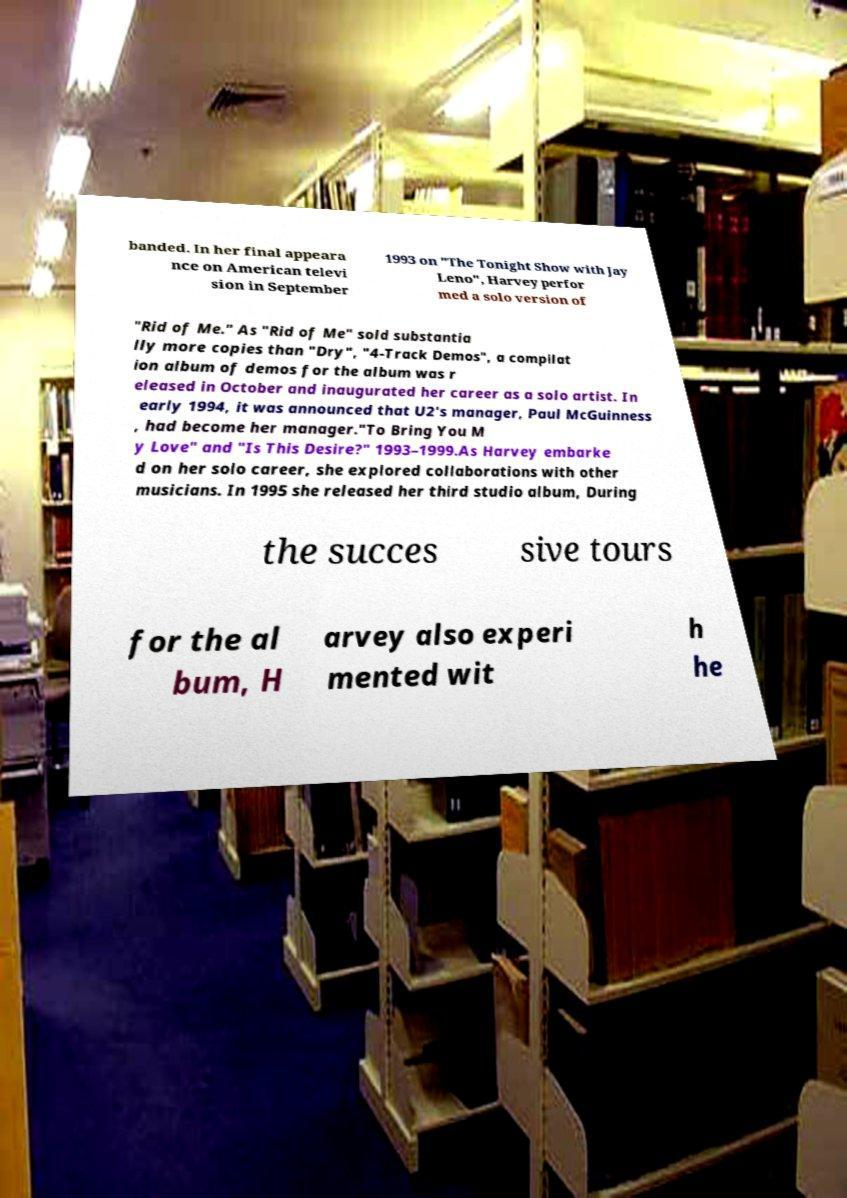For documentation purposes, I need the text within this image transcribed. Could you provide that? banded. In her final appeara nce on American televi sion in September 1993 on "The Tonight Show with Jay Leno", Harvey perfor med a solo version of "Rid of Me." As "Rid of Me" sold substantia lly more copies than "Dry", "4-Track Demos", a compilat ion album of demos for the album was r eleased in October and inaugurated her career as a solo artist. In early 1994, it was announced that U2's manager, Paul McGuinness , had become her manager."To Bring You M y Love" and "Is This Desire?" 1993–1999.As Harvey embarke d on her solo career, she explored collaborations with other musicians. In 1995 she released her third studio album, During the succes sive tours for the al bum, H arvey also experi mented wit h he 